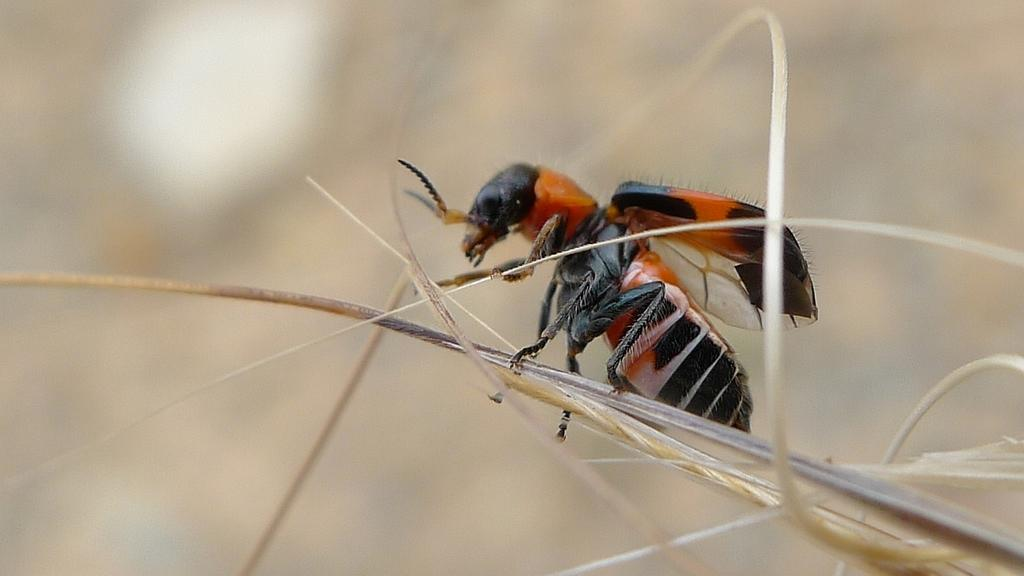What is the main subject of the picture? The main subject of the picture is an insect. Where is the insect located in the image? The insect is on a stem. Can you describe the background of the image? The background of the image is blurred. What is the owner of the tiger doing in the image? There is no tiger or owner present in the image; it features an insect on a stem with a blurred background. 